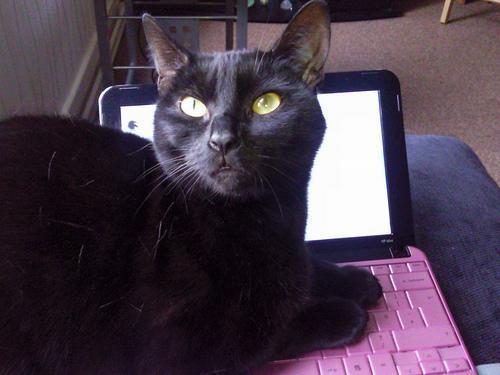How many cats are in the picture?
Give a very brief answer. 1. 